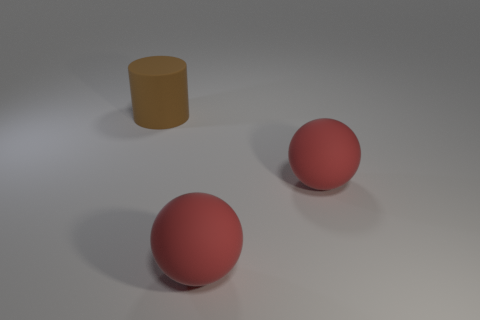Subtract all yellow spheres. Subtract all cyan cylinders. How many spheres are left? 2 Add 2 metallic cubes. How many objects exist? 5 Subtract all cylinders. How many objects are left? 2 Subtract all brown cylinders. Subtract all big cubes. How many objects are left? 2 Add 3 rubber spheres. How many rubber spheres are left? 5 Add 2 gray metallic cylinders. How many gray metallic cylinders exist? 2 Subtract 0 gray spheres. How many objects are left? 3 